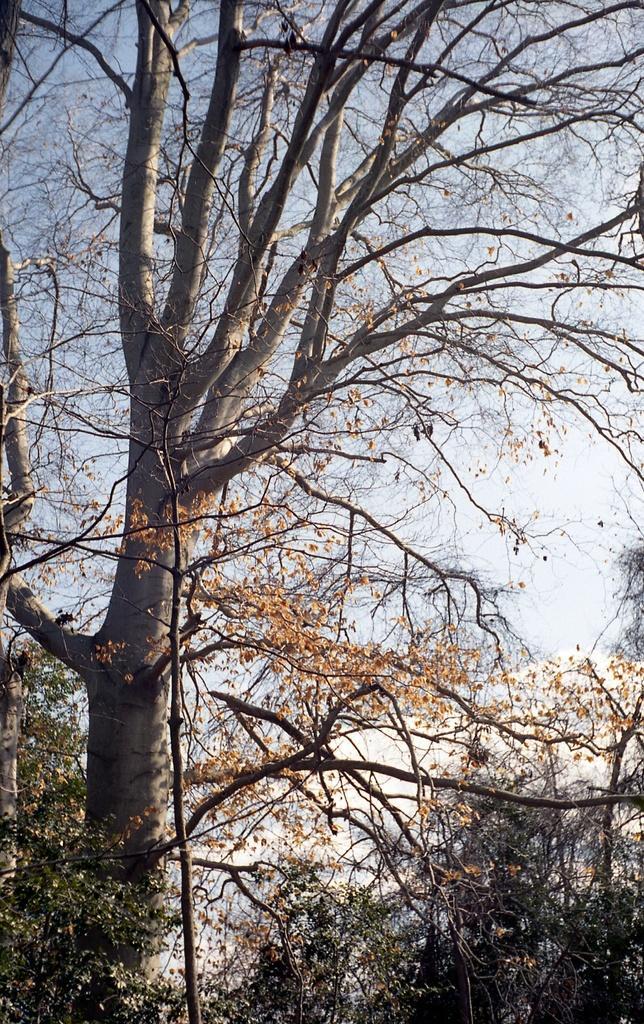Describe this image in one or two sentences. In this image the foreground there are some trees, and in the background there is sky. 